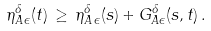Convert formula to latex. <formula><loc_0><loc_0><loc_500><loc_500>\eta ^ { \delta } _ { A \, \epsilon } ( t ) \, \geq \, \eta ^ { \delta } _ { A \, \epsilon } ( s ) + G ^ { \delta } _ { A \epsilon } ( s , t ) \, .</formula> 